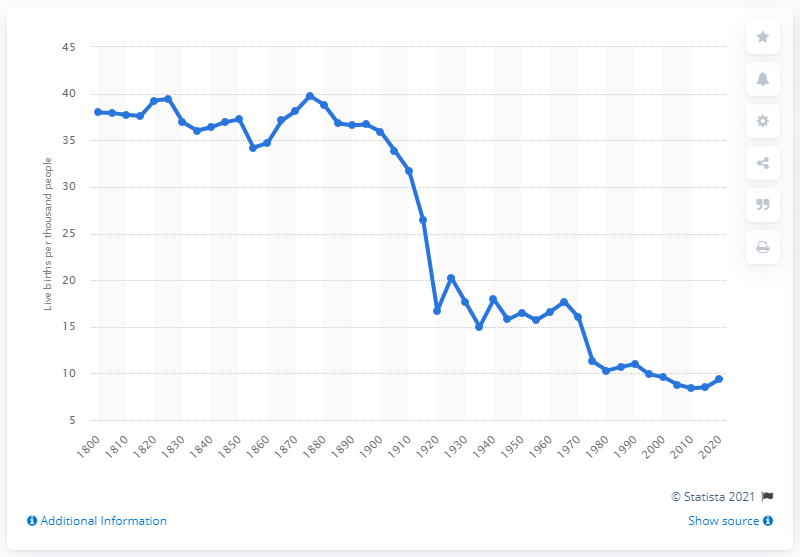Highlight a few significant elements in this photo. Germany's crude birth rate in 1980 was 10.3. 